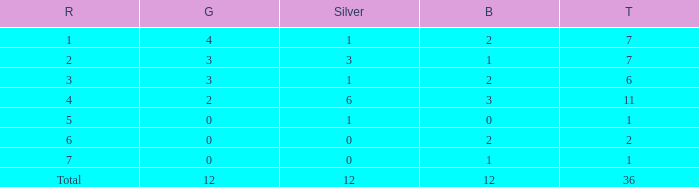What is the highest number of silver medals for a team with total less than 1? None. 